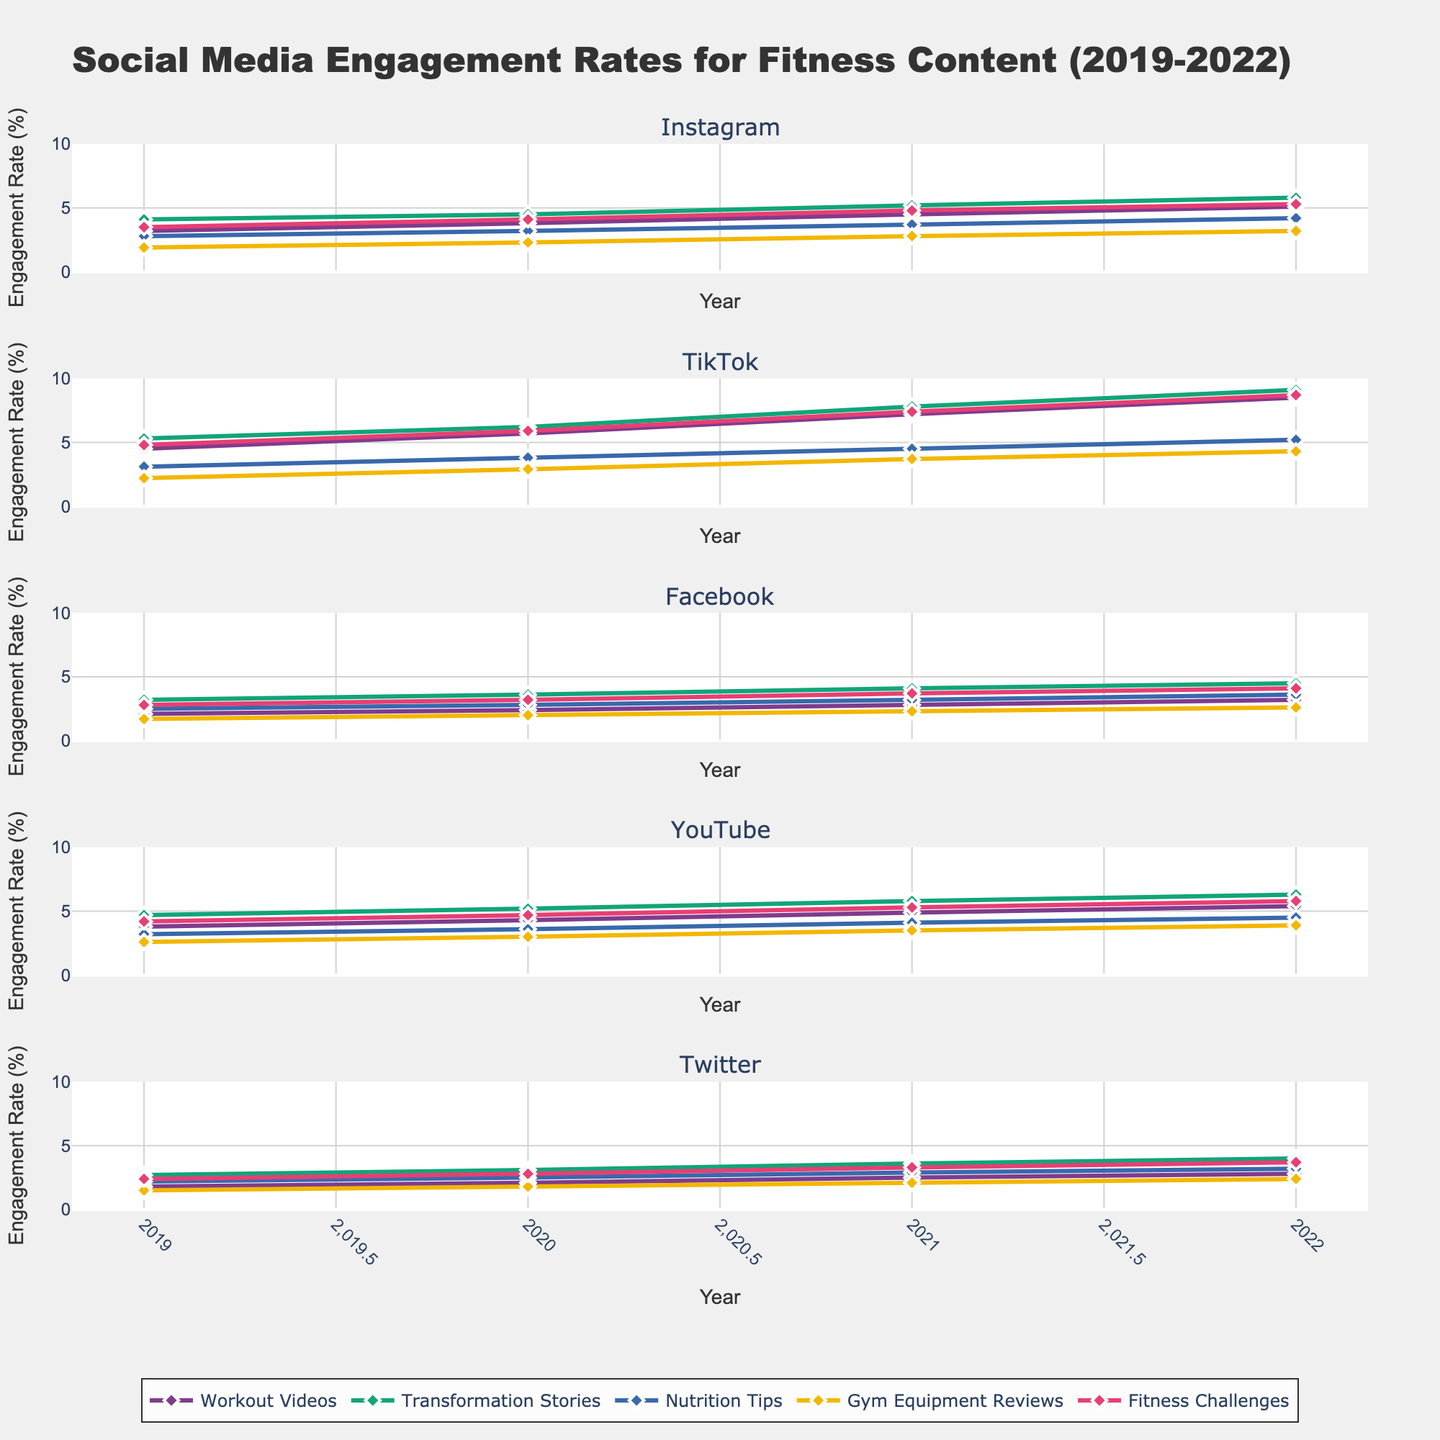What platform showed the highest engagement rate for "Workout Videos" in 2022? First, look at the "Workout Videos" line for each platform's subplot in 2022. The platform with the highest point on this line will be the answer. TikTok's engagement rate for "Workout Videos" in 2022 is 8.5%, which is the highest among all platforms.
Answer: TikTok How did the engagement rate for "Nutrition Tips" on Instagram change from 2019 to 2022? Identify the "Nutrition Tips" line in Instagram's subplot and compare the engagement rates at 2019 and 2022. In 2019, the rate is 2.8%, and in 2022, it is 4.2%. The change is calculated as 4.2% - 2.8% = 1.4%.
Answer: Increased by 1.4% Which content type had the highest growth in engagement rate on all platforms from 2019 to 2022? Examine the difference between engagement rates in 2022 and 2019 for each content type across all platforms. The “Fitness Challenges” content type shows the highest increase, particularly in TikTok (8.7% in 2022 vs. 4.8% in 2019, a difference of 3.9%).
Answer: Fitness Challenges In 2021, which platform had the lowest engagement rate for "Gym Equipment Reviews"? Locate the engagement rates for "Gym Equipment Reviews" in 2021 across all platforms. Identify the minimum value and corresponding platform. Twitter had the lowest engagement rate for "Gym Equipment Reviews" in 2021, which is 2.1%.
Answer: Twitter What is the average engagement rate for "Transformation Stories" across all platforms in 2020? Identify the engagement rates for "Transformation Stories" on each platform in 2020, sum them, and divide by the number of platforms. The rates are Instagram (4.5), TikTok (6.2), Facebook (3.6), YouTube (5.2), and Twitter (3.1). Calculate the sum (4.5 + 6.2 + 3.6 + 5.2 + 3.1 = 22.6) and divide by 5 (22.6 / 5).
Answer: 4.52 Which platform has shown a constant increase in "Workout Videos" engagement every year? Observe the "Workout Videos" line across years (2019-2022) for each platform. Identify which line shows a continuous upward trend without any decrease. Instagram consistently shows an increase in engagement rates for "Workout Videos".
Answer: Instagram In 2022, how does the engagement rate for "Fitness Challenges" on YouTube compare to the rate on Facebook? Identify the engagement rates for "Fitness Challenges" on YouTube and Facebook in 2022. YouTube's rate is 5.8%, and Facebook's rate is 4.1%. Compare the two values.
Answer: YouTube is 1.7% higher What is the median engagement rate for "Workout Videos" on YouTube from 2019 to 2022? Find the engagement rates for "Workout Videos" on YouTube for each year (3.8, 4.3, 4.9, 5.4). Arrange them in ascending order (3.8, 4.3, 4.9, 5.4). Since there are four values, the median is the average of the two middle values (4.3 + 4.9) / 2.
Answer: 4.6 By how much did TikTok's engagement rate for "Transformation Stories" increase from 2021 to 2022? Identify the engagement rates for "Transformation Stories" on TikTok in 2021 (7.8%) and 2022 (9.1%). Compute the difference (9.1 - 7.8).
Answer: 1.3% Which content type consistently had the lowest engagement across all platforms in 2019? Compare the engagement rates of all content types across platforms in 2019. Identify which content type has the lowest values in each case. "Gym Equipment Reviews" has the lowest engagement rates across most platforms in 2019.
Answer: Gym Equipment Reviews 